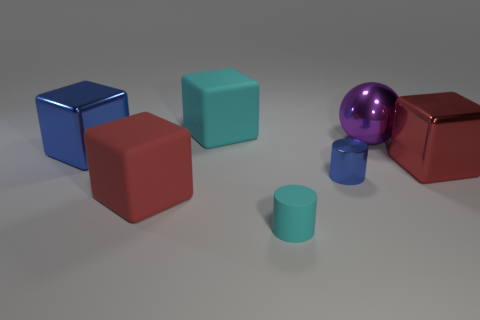Are there any cyan matte things of the same size as the purple shiny object?
Offer a very short reply. Yes. There is a cyan block behind the blue cylinder; is it the same size as the tiny cyan object?
Your answer should be compact. No. What is the shape of the metallic object that is in front of the blue metallic block and to the right of the small metallic object?
Give a very brief answer. Cube. Are there more big cyan matte cubes that are to the right of the small rubber cylinder than small gray cylinders?
Your answer should be very brief. No. The red thing that is the same material as the large purple ball is what size?
Give a very brief answer. Large. What number of small things have the same color as the ball?
Offer a terse response. 0. There is a large matte object that is in front of the metallic cylinder; is its color the same as the large shiny sphere?
Your answer should be very brief. No. Is the number of large cyan matte cubes that are in front of the big red rubber block the same as the number of red shiny blocks to the left of the tiny metal object?
Make the answer very short. Yes. Are there any other things that have the same material as the blue cylinder?
Keep it short and to the point. Yes. What color is the large rubber thing that is behind the purple shiny ball?
Ensure brevity in your answer.  Cyan. 